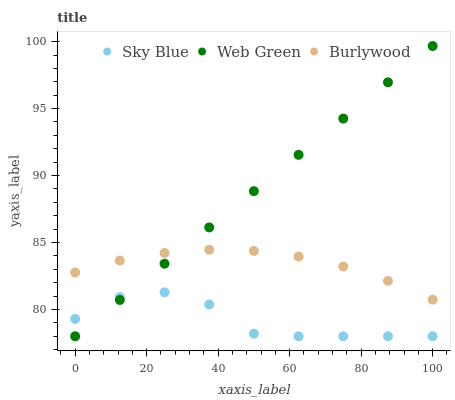Does Sky Blue have the minimum area under the curve?
Answer yes or no. Yes. Does Web Green have the maximum area under the curve?
Answer yes or no. Yes. Does Web Green have the minimum area under the curve?
Answer yes or no. No. Does Sky Blue have the maximum area under the curve?
Answer yes or no. No. Is Web Green the smoothest?
Answer yes or no. Yes. Is Sky Blue the roughest?
Answer yes or no. Yes. Is Sky Blue the smoothest?
Answer yes or no. No. Is Web Green the roughest?
Answer yes or no. No. Does Sky Blue have the lowest value?
Answer yes or no. Yes. Does Web Green have the highest value?
Answer yes or no. Yes. Does Sky Blue have the highest value?
Answer yes or no. No. Is Sky Blue less than Burlywood?
Answer yes or no. Yes. Is Burlywood greater than Sky Blue?
Answer yes or no. Yes. Does Web Green intersect Sky Blue?
Answer yes or no. Yes. Is Web Green less than Sky Blue?
Answer yes or no. No. Is Web Green greater than Sky Blue?
Answer yes or no. No. Does Sky Blue intersect Burlywood?
Answer yes or no. No. 